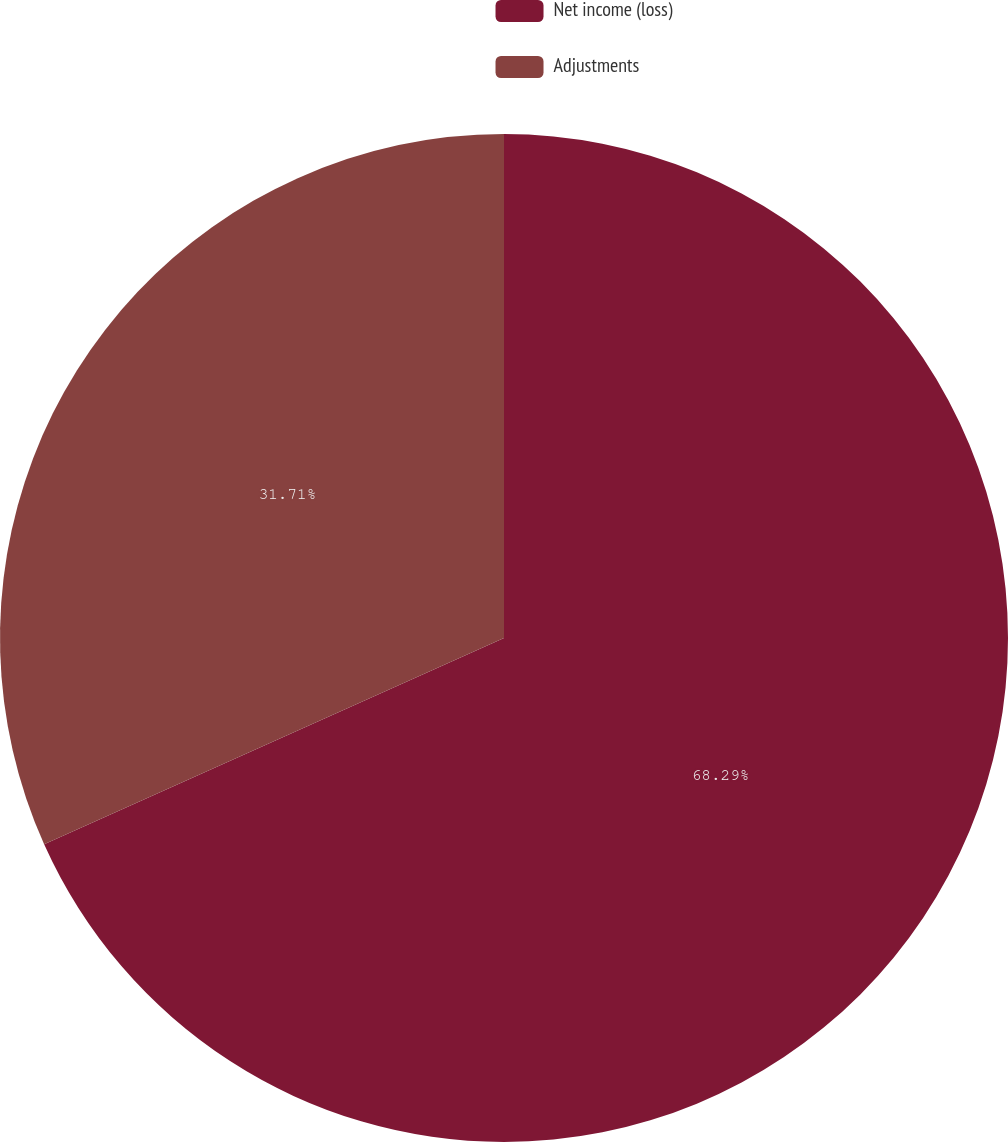Convert chart. <chart><loc_0><loc_0><loc_500><loc_500><pie_chart><fcel>Net income (loss)<fcel>Adjustments<nl><fcel>68.29%<fcel>31.71%<nl></chart> 